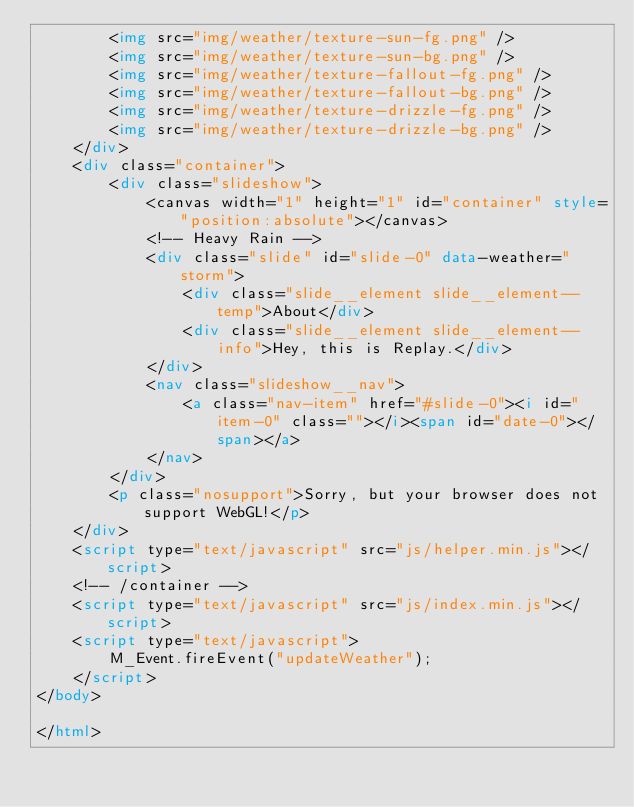Convert code to text. <code><loc_0><loc_0><loc_500><loc_500><_HTML_>		<img src="img/weather/texture-sun-fg.png" />
		<img src="img/weather/texture-sun-bg.png" />
		<img src="img/weather/texture-fallout-fg.png" />
		<img src="img/weather/texture-fallout-bg.png" />
		<img src="img/weather/texture-drizzle-fg.png" />
		<img src="img/weather/texture-drizzle-bg.png" />
	</div>
	<div class="container">
		<div class="slideshow">
			<canvas width="1" height="1" id="container" style="position:absolute"></canvas>
			<!-- Heavy Rain -->
			<div class="slide" id="slide-0" data-weather="storm">
				<div class="slide__element slide__element--temp">About</div>
				<div class="slide__element slide__element--info">Hey, this is Replay.</div>
			</div>
			<nav class="slideshow__nav">
				<a class="nav-item" href="#slide-0"><i id="item-0" class=""></i><span id="date-0"></span></a>
			</nav>
		</div>
		<p class="nosupport">Sorry, but your browser does not support WebGL!</p>
	</div>
	<script type="text/javascript" src="js/helper.min.js"></script>
	<!-- /container -->
	<script type="text/javascript" src="js/index.min.js"></script>
	<script type="text/javascript">
		M_Event.fireEvent("updateWeather");
	</script>	
</body>

</html>
</code> 